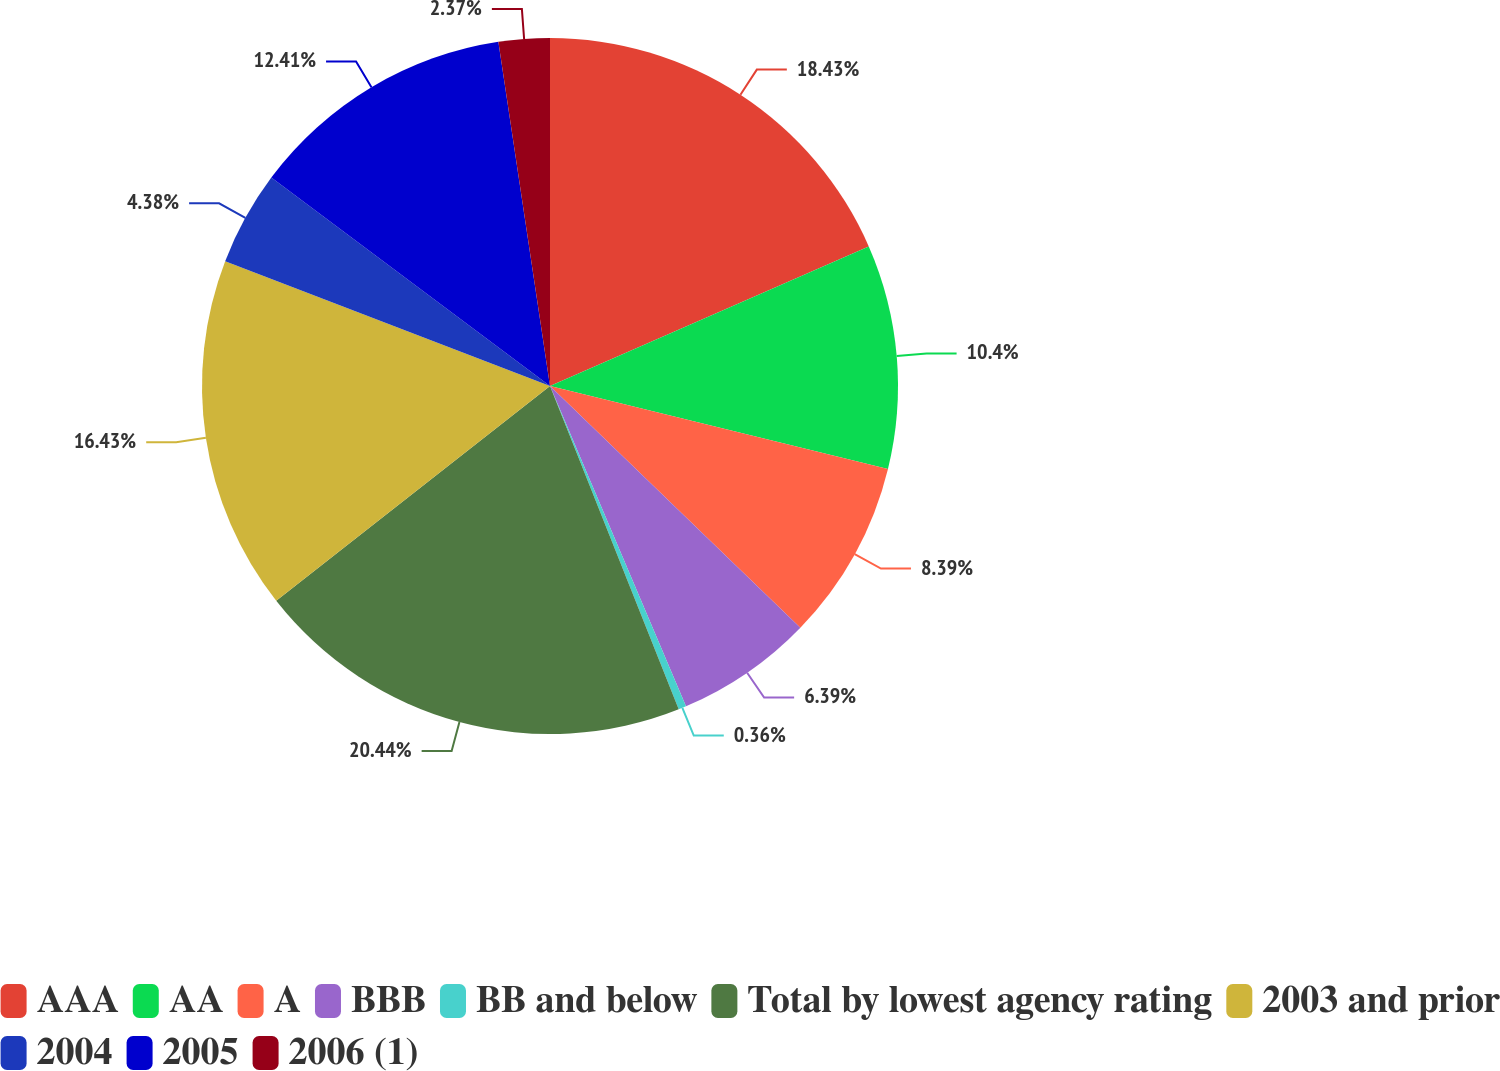Convert chart. <chart><loc_0><loc_0><loc_500><loc_500><pie_chart><fcel>AAA<fcel>AA<fcel>A<fcel>BBB<fcel>BB and below<fcel>Total by lowest agency rating<fcel>2003 and prior<fcel>2004<fcel>2005<fcel>2006 (1)<nl><fcel>18.43%<fcel>10.4%<fcel>8.39%<fcel>6.39%<fcel>0.36%<fcel>20.44%<fcel>16.43%<fcel>4.38%<fcel>12.41%<fcel>2.37%<nl></chart> 